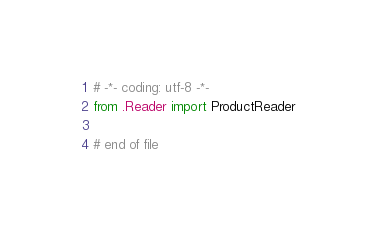Convert code to text. <code><loc_0><loc_0><loc_500><loc_500><_Python_># -*- coding: utf-8 -*-
from .Reader import ProductReader

# end of file

</code> 